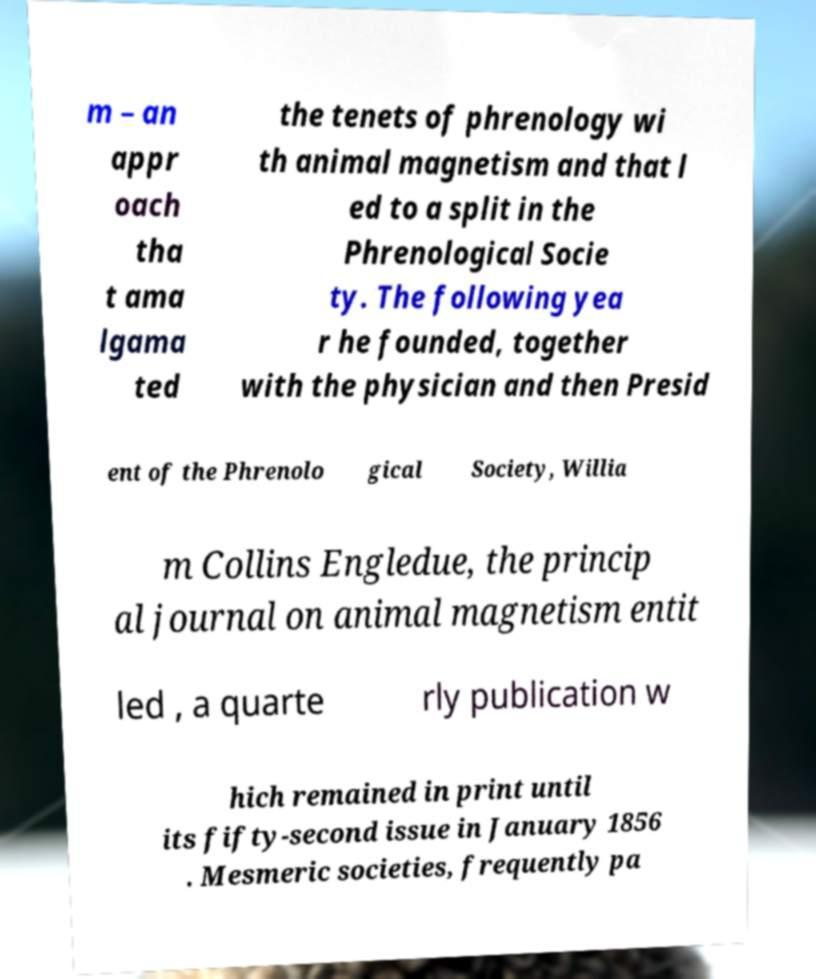Can you accurately transcribe the text from the provided image for me? m – an appr oach tha t ama lgama ted the tenets of phrenology wi th animal magnetism and that l ed to a split in the Phrenological Socie ty. The following yea r he founded, together with the physician and then Presid ent of the Phrenolo gical Society, Willia m Collins Engledue, the princip al journal on animal magnetism entit led , a quarte rly publication w hich remained in print until its fifty-second issue in January 1856 . Mesmeric societies, frequently pa 